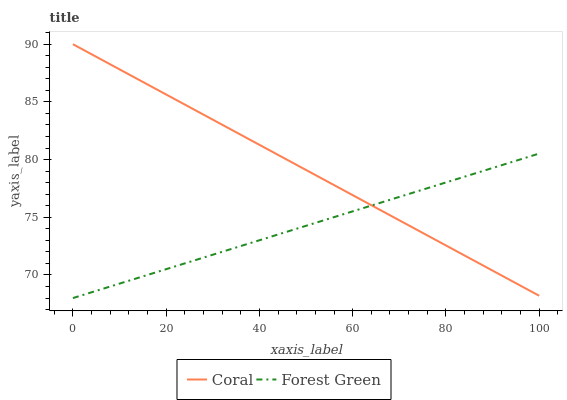Does Forest Green have the minimum area under the curve?
Answer yes or no. Yes. Does Coral have the maximum area under the curve?
Answer yes or no. Yes. Does Forest Green have the maximum area under the curve?
Answer yes or no. No. Is Forest Green the smoothest?
Answer yes or no. Yes. Is Coral the roughest?
Answer yes or no. Yes. Is Forest Green the roughest?
Answer yes or no. No. Does Forest Green have the lowest value?
Answer yes or no. Yes. Does Coral have the highest value?
Answer yes or no. Yes. Does Forest Green have the highest value?
Answer yes or no. No. Does Coral intersect Forest Green?
Answer yes or no. Yes. Is Coral less than Forest Green?
Answer yes or no. No. Is Coral greater than Forest Green?
Answer yes or no. No. 